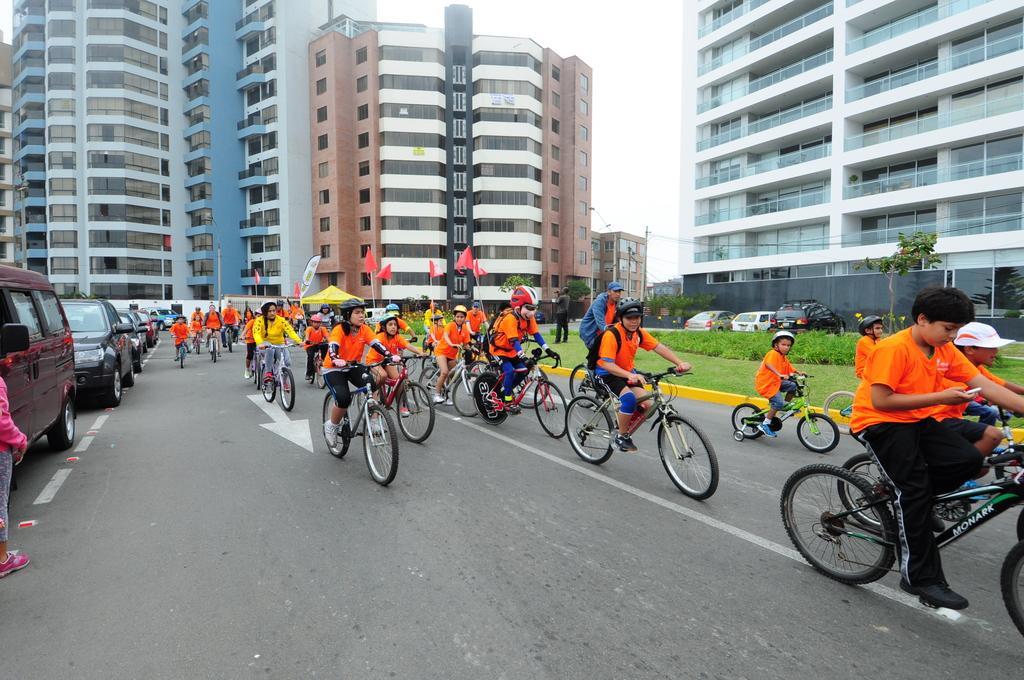Describe this image in one or two sentences. In this picture, there are buildings around the area of the image and there are group of people those who are riding the bicycle, it seems to be a competition and there are trees at the right and left side of the image, there is grass floor at the right side of the image, it is a day time, the other people those who are standing at the left side of the image they are watching the competition, there are cars around the area of the image. 